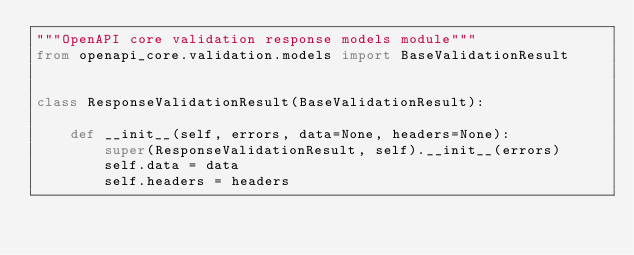<code> <loc_0><loc_0><loc_500><loc_500><_Python_>"""OpenAPI core validation response models module"""
from openapi_core.validation.models import BaseValidationResult


class ResponseValidationResult(BaseValidationResult):

    def __init__(self, errors, data=None, headers=None):
        super(ResponseValidationResult, self).__init__(errors)
        self.data = data
        self.headers = headers
</code> 